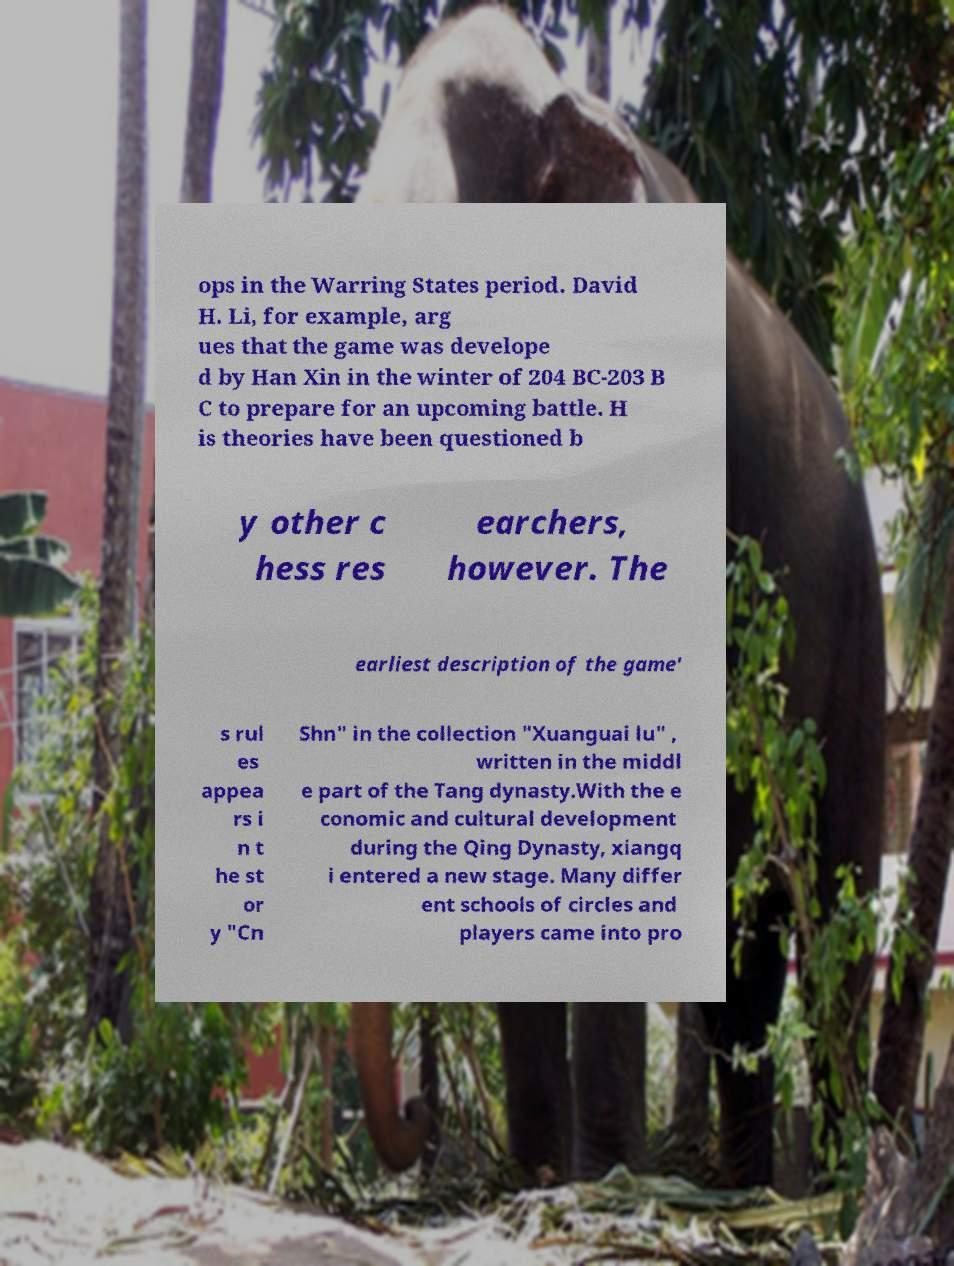Could you extract and type out the text from this image? ops in the Warring States period. David H. Li, for example, arg ues that the game was develope d by Han Xin in the winter of 204 BC-203 B C to prepare for an upcoming battle. H is theories have been questioned b y other c hess res earchers, however. The earliest description of the game' s rul es appea rs i n t he st or y "Cn Shn" in the collection "Xuanguai lu" , written in the middl e part of the Tang dynasty.With the e conomic and cultural development during the Qing Dynasty, xiangq i entered a new stage. Many differ ent schools of circles and players came into pro 